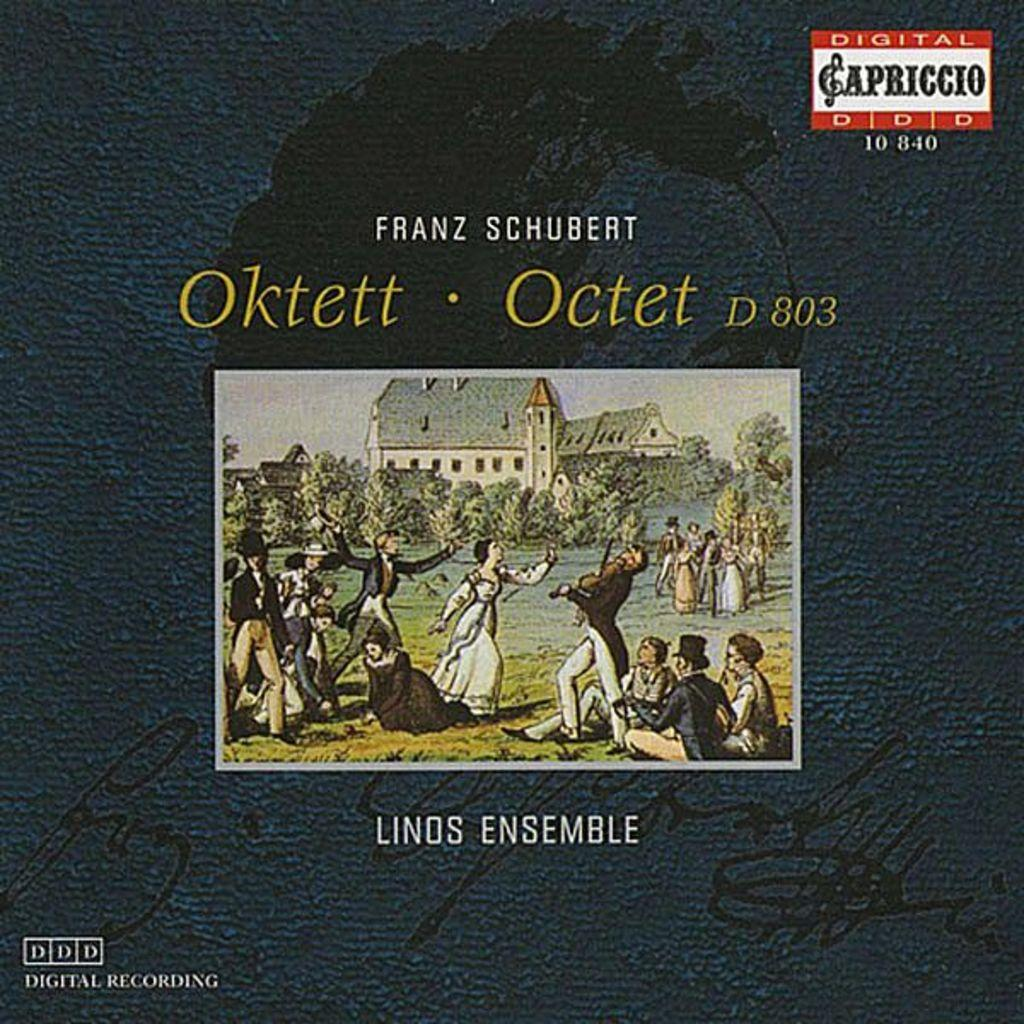<image>
Present a compact description of the photo's key features. An old time painting is used to advertise Frank Schubert Linds Ensemble. 